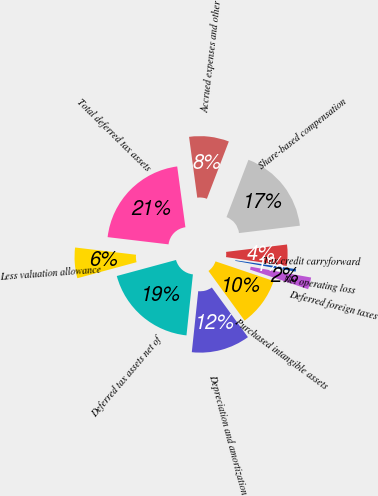Convert chart to OTSL. <chart><loc_0><loc_0><loc_500><loc_500><pie_chart><fcel>Net operating loss<fcel>Tax credit carryforward<fcel>Share-based compensation<fcel>Accrued expenses and other<fcel>Total deferred tax assets<fcel>Less valuation allowance<fcel>Deferred tax assets net of<fcel>Depreciation and amortization<fcel>Purchased intangible assets<fcel>Deferred foreign taxes<nl><fcel>0.5%<fcel>4.23%<fcel>17.26%<fcel>7.95%<fcel>20.98%<fcel>6.09%<fcel>19.12%<fcel>11.68%<fcel>9.81%<fcel>2.37%<nl></chart> 